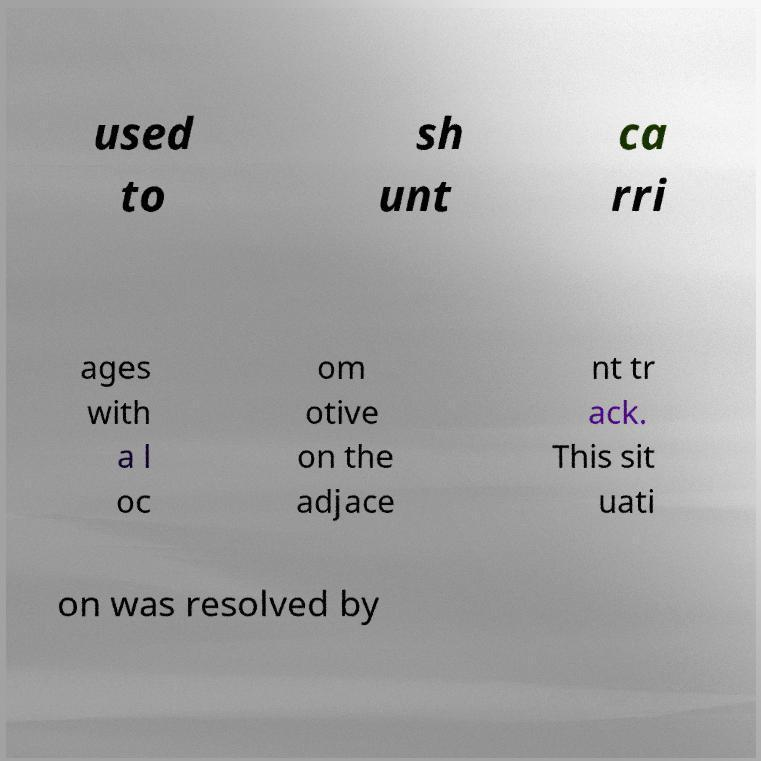Could you assist in decoding the text presented in this image and type it out clearly? used to sh unt ca rri ages with a l oc om otive on the adjace nt tr ack. This sit uati on was resolved by 